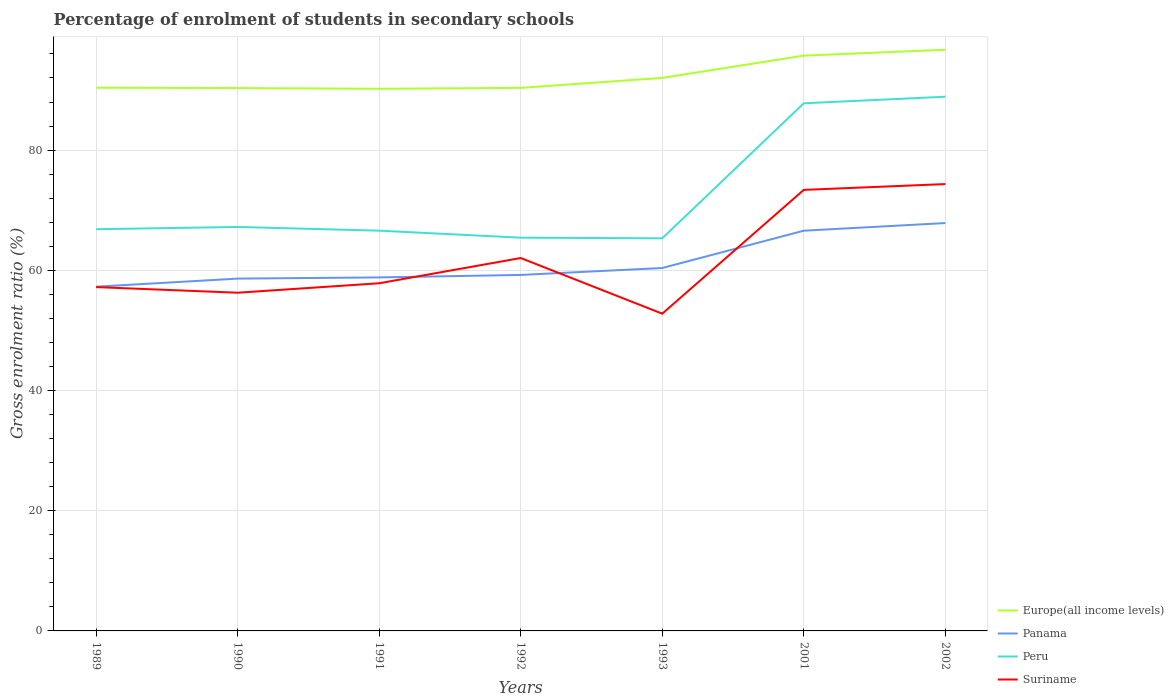How many different coloured lines are there?
Provide a short and direct response. 4. Is the number of lines equal to the number of legend labels?
Your response must be concise. Yes. Across all years, what is the maximum percentage of students enrolled in secondary schools in Europe(all income levels)?
Provide a succinct answer. 90.2. In which year was the percentage of students enrolled in secondary schools in Europe(all income levels) maximum?
Keep it short and to the point. 1991. What is the total percentage of students enrolled in secondary schools in Europe(all income levels) in the graph?
Offer a terse response. -1.66. What is the difference between the highest and the second highest percentage of students enrolled in secondary schools in Panama?
Offer a terse response. 10.59. What is the difference between the highest and the lowest percentage of students enrolled in secondary schools in Panama?
Offer a very short reply. 2. Does the graph contain grids?
Provide a short and direct response. Yes. What is the title of the graph?
Your response must be concise. Percentage of enrolment of students in secondary schools. Does "Guatemala" appear as one of the legend labels in the graph?
Make the answer very short. No. What is the Gross enrolment ratio (%) in Europe(all income levels) in 1989?
Ensure brevity in your answer.  90.38. What is the Gross enrolment ratio (%) in Panama in 1989?
Provide a succinct answer. 57.27. What is the Gross enrolment ratio (%) in Peru in 1989?
Provide a short and direct response. 66.84. What is the Gross enrolment ratio (%) of Suriname in 1989?
Keep it short and to the point. 57.21. What is the Gross enrolment ratio (%) of Europe(all income levels) in 1990?
Ensure brevity in your answer.  90.32. What is the Gross enrolment ratio (%) in Panama in 1990?
Your answer should be very brief. 58.62. What is the Gross enrolment ratio (%) of Peru in 1990?
Make the answer very short. 67.21. What is the Gross enrolment ratio (%) in Suriname in 1990?
Your answer should be compact. 56.27. What is the Gross enrolment ratio (%) in Europe(all income levels) in 1991?
Your answer should be very brief. 90.2. What is the Gross enrolment ratio (%) in Panama in 1991?
Keep it short and to the point. 58.82. What is the Gross enrolment ratio (%) in Peru in 1991?
Your answer should be compact. 66.59. What is the Gross enrolment ratio (%) in Suriname in 1991?
Your response must be concise. 57.85. What is the Gross enrolment ratio (%) of Europe(all income levels) in 1992?
Your answer should be compact. 90.36. What is the Gross enrolment ratio (%) in Panama in 1992?
Give a very brief answer. 59.23. What is the Gross enrolment ratio (%) of Peru in 1992?
Make the answer very short. 65.43. What is the Gross enrolment ratio (%) in Suriname in 1992?
Your answer should be very brief. 62.04. What is the Gross enrolment ratio (%) of Europe(all income levels) in 1993?
Ensure brevity in your answer.  92.02. What is the Gross enrolment ratio (%) in Panama in 1993?
Your answer should be very brief. 60.38. What is the Gross enrolment ratio (%) of Peru in 1993?
Provide a succinct answer. 65.32. What is the Gross enrolment ratio (%) of Suriname in 1993?
Provide a short and direct response. 52.78. What is the Gross enrolment ratio (%) in Europe(all income levels) in 2001?
Your answer should be compact. 95.72. What is the Gross enrolment ratio (%) of Panama in 2001?
Provide a short and direct response. 66.59. What is the Gross enrolment ratio (%) of Peru in 2001?
Your answer should be compact. 87.79. What is the Gross enrolment ratio (%) in Suriname in 2001?
Give a very brief answer. 73.38. What is the Gross enrolment ratio (%) in Europe(all income levels) in 2002?
Your answer should be very brief. 96.69. What is the Gross enrolment ratio (%) of Panama in 2002?
Ensure brevity in your answer.  67.86. What is the Gross enrolment ratio (%) of Peru in 2002?
Offer a very short reply. 88.88. What is the Gross enrolment ratio (%) in Suriname in 2002?
Provide a succinct answer. 74.35. Across all years, what is the maximum Gross enrolment ratio (%) of Europe(all income levels)?
Your answer should be very brief. 96.69. Across all years, what is the maximum Gross enrolment ratio (%) of Panama?
Provide a succinct answer. 67.86. Across all years, what is the maximum Gross enrolment ratio (%) of Peru?
Provide a short and direct response. 88.88. Across all years, what is the maximum Gross enrolment ratio (%) in Suriname?
Provide a succinct answer. 74.35. Across all years, what is the minimum Gross enrolment ratio (%) of Europe(all income levels)?
Offer a terse response. 90.2. Across all years, what is the minimum Gross enrolment ratio (%) of Panama?
Provide a succinct answer. 57.27. Across all years, what is the minimum Gross enrolment ratio (%) in Peru?
Give a very brief answer. 65.32. Across all years, what is the minimum Gross enrolment ratio (%) in Suriname?
Give a very brief answer. 52.78. What is the total Gross enrolment ratio (%) in Europe(all income levels) in the graph?
Offer a terse response. 645.69. What is the total Gross enrolment ratio (%) of Panama in the graph?
Make the answer very short. 428.78. What is the total Gross enrolment ratio (%) of Peru in the graph?
Keep it short and to the point. 508.06. What is the total Gross enrolment ratio (%) in Suriname in the graph?
Provide a succinct answer. 433.88. What is the difference between the Gross enrolment ratio (%) of Europe(all income levels) in 1989 and that in 1990?
Provide a short and direct response. 0.06. What is the difference between the Gross enrolment ratio (%) in Panama in 1989 and that in 1990?
Your answer should be compact. -1.34. What is the difference between the Gross enrolment ratio (%) of Peru in 1989 and that in 1990?
Offer a very short reply. -0.38. What is the difference between the Gross enrolment ratio (%) of Suriname in 1989 and that in 1990?
Your response must be concise. 0.94. What is the difference between the Gross enrolment ratio (%) of Europe(all income levels) in 1989 and that in 1991?
Provide a short and direct response. 0.18. What is the difference between the Gross enrolment ratio (%) of Panama in 1989 and that in 1991?
Offer a very short reply. -1.54. What is the difference between the Gross enrolment ratio (%) of Peru in 1989 and that in 1991?
Give a very brief answer. 0.24. What is the difference between the Gross enrolment ratio (%) of Suriname in 1989 and that in 1991?
Provide a succinct answer. -0.64. What is the difference between the Gross enrolment ratio (%) of Europe(all income levels) in 1989 and that in 1992?
Your answer should be compact. 0.03. What is the difference between the Gross enrolment ratio (%) of Panama in 1989 and that in 1992?
Offer a terse response. -1.96. What is the difference between the Gross enrolment ratio (%) in Peru in 1989 and that in 1992?
Your response must be concise. 1.41. What is the difference between the Gross enrolment ratio (%) in Suriname in 1989 and that in 1992?
Ensure brevity in your answer.  -4.84. What is the difference between the Gross enrolment ratio (%) of Europe(all income levels) in 1989 and that in 1993?
Make the answer very short. -1.63. What is the difference between the Gross enrolment ratio (%) of Panama in 1989 and that in 1993?
Make the answer very short. -3.11. What is the difference between the Gross enrolment ratio (%) in Peru in 1989 and that in 1993?
Ensure brevity in your answer.  1.51. What is the difference between the Gross enrolment ratio (%) of Suriname in 1989 and that in 1993?
Give a very brief answer. 4.42. What is the difference between the Gross enrolment ratio (%) in Europe(all income levels) in 1989 and that in 2001?
Ensure brevity in your answer.  -5.34. What is the difference between the Gross enrolment ratio (%) in Panama in 1989 and that in 2001?
Your answer should be very brief. -9.32. What is the difference between the Gross enrolment ratio (%) in Peru in 1989 and that in 2001?
Your answer should be compact. -20.95. What is the difference between the Gross enrolment ratio (%) in Suriname in 1989 and that in 2001?
Your response must be concise. -16.17. What is the difference between the Gross enrolment ratio (%) of Europe(all income levels) in 1989 and that in 2002?
Offer a very short reply. -6.31. What is the difference between the Gross enrolment ratio (%) of Panama in 1989 and that in 2002?
Your response must be concise. -10.59. What is the difference between the Gross enrolment ratio (%) in Peru in 1989 and that in 2002?
Your answer should be very brief. -22.04. What is the difference between the Gross enrolment ratio (%) of Suriname in 1989 and that in 2002?
Your response must be concise. -17.14. What is the difference between the Gross enrolment ratio (%) of Europe(all income levels) in 1990 and that in 1991?
Offer a terse response. 0.12. What is the difference between the Gross enrolment ratio (%) of Panama in 1990 and that in 1991?
Provide a short and direct response. -0.2. What is the difference between the Gross enrolment ratio (%) in Peru in 1990 and that in 1991?
Your answer should be very brief. 0.62. What is the difference between the Gross enrolment ratio (%) of Suriname in 1990 and that in 1991?
Your answer should be very brief. -1.57. What is the difference between the Gross enrolment ratio (%) in Europe(all income levels) in 1990 and that in 1992?
Provide a succinct answer. -0.04. What is the difference between the Gross enrolment ratio (%) in Panama in 1990 and that in 1992?
Your response must be concise. -0.61. What is the difference between the Gross enrolment ratio (%) of Peru in 1990 and that in 1992?
Ensure brevity in your answer.  1.79. What is the difference between the Gross enrolment ratio (%) of Suriname in 1990 and that in 1992?
Provide a short and direct response. -5.77. What is the difference between the Gross enrolment ratio (%) of Europe(all income levels) in 1990 and that in 1993?
Offer a very short reply. -1.69. What is the difference between the Gross enrolment ratio (%) in Panama in 1990 and that in 1993?
Provide a short and direct response. -1.76. What is the difference between the Gross enrolment ratio (%) in Peru in 1990 and that in 1993?
Ensure brevity in your answer.  1.89. What is the difference between the Gross enrolment ratio (%) of Suriname in 1990 and that in 1993?
Provide a succinct answer. 3.49. What is the difference between the Gross enrolment ratio (%) in Europe(all income levels) in 1990 and that in 2001?
Make the answer very short. -5.4. What is the difference between the Gross enrolment ratio (%) in Panama in 1990 and that in 2001?
Provide a succinct answer. -7.97. What is the difference between the Gross enrolment ratio (%) in Peru in 1990 and that in 2001?
Give a very brief answer. -20.57. What is the difference between the Gross enrolment ratio (%) of Suriname in 1990 and that in 2001?
Your answer should be very brief. -17.11. What is the difference between the Gross enrolment ratio (%) of Europe(all income levels) in 1990 and that in 2002?
Ensure brevity in your answer.  -6.37. What is the difference between the Gross enrolment ratio (%) in Panama in 1990 and that in 2002?
Offer a very short reply. -9.24. What is the difference between the Gross enrolment ratio (%) of Peru in 1990 and that in 2002?
Your response must be concise. -21.67. What is the difference between the Gross enrolment ratio (%) in Suriname in 1990 and that in 2002?
Offer a very short reply. -18.07. What is the difference between the Gross enrolment ratio (%) in Europe(all income levels) in 1991 and that in 1992?
Your answer should be compact. -0.16. What is the difference between the Gross enrolment ratio (%) of Panama in 1991 and that in 1992?
Provide a short and direct response. -0.41. What is the difference between the Gross enrolment ratio (%) of Peru in 1991 and that in 1992?
Make the answer very short. 1.17. What is the difference between the Gross enrolment ratio (%) in Suriname in 1991 and that in 1992?
Provide a succinct answer. -4.2. What is the difference between the Gross enrolment ratio (%) in Europe(all income levels) in 1991 and that in 1993?
Provide a short and direct response. -1.81. What is the difference between the Gross enrolment ratio (%) in Panama in 1991 and that in 1993?
Ensure brevity in your answer.  -1.56. What is the difference between the Gross enrolment ratio (%) in Peru in 1991 and that in 1993?
Your answer should be compact. 1.27. What is the difference between the Gross enrolment ratio (%) of Suriname in 1991 and that in 1993?
Offer a very short reply. 5.06. What is the difference between the Gross enrolment ratio (%) of Europe(all income levels) in 1991 and that in 2001?
Provide a short and direct response. -5.52. What is the difference between the Gross enrolment ratio (%) in Panama in 1991 and that in 2001?
Offer a terse response. -7.77. What is the difference between the Gross enrolment ratio (%) in Peru in 1991 and that in 2001?
Ensure brevity in your answer.  -21.19. What is the difference between the Gross enrolment ratio (%) in Suriname in 1991 and that in 2001?
Offer a very short reply. -15.54. What is the difference between the Gross enrolment ratio (%) in Europe(all income levels) in 1991 and that in 2002?
Give a very brief answer. -6.49. What is the difference between the Gross enrolment ratio (%) of Panama in 1991 and that in 2002?
Ensure brevity in your answer.  -9.04. What is the difference between the Gross enrolment ratio (%) of Peru in 1991 and that in 2002?
Provide a short and direct response. -22.28. What is the difference between the Gross enrolment ratio (%) of Suriname in 1991 and that in 2002?
Keep it short and to the point. -16.5. What is the difference between the Gross enrolment ratio (%) of Europe(all income levels) in 1992 and that in 1993?
Provide a succinct answer. -1.66. What is the difference between the Gross enrolment ratio (%) of Panama in 1992 and that in 1993?
Your answer should be very brief. -1.15. What is the difference between the Gross enrolment ratio (%) in Peru in 1992 and that in 1993?
Give a very brief answer. 0.1. What is the difference between the Gross enrolment ratio (%) in Suriname in 1992 and that in 1993?
Offer a very short reply. 9.26. What is the difference between the Gross enrolment ratio (%) of Europe(all income levels) in 1992 and that in 2001?
Your answer should be compact. -5.36. What is the difference between the Gross enrolment ratio (%) of Panama in 1992 and that in 2001?
Provide a short and direct response. -7.36. What is the difference between the Gross enrolment ratio (%) in Peru in 1992 and that in 2001?
Keep it short and to the point. -22.36. What is the difference between the Gross enrolment ratio (%) in Suriname in 1992 and that in 2001?
Your answer should be very brief. -11.34. What is the difference between the Gross enrolment ratio (%) in Europe(all income levels) in 1992 and that in 2002?
Ensure brevity in your answer.  -6.34. What is the difference between the Gross enrolment ratio (%) in Panama in 1992 and that in 2002?
Your answer should be very brief. -8.63. What is the difference between the Gross enrolment ratio (%) in Peru in 1992 and that in 2002?
Offer a terse response. -23.45. What is the difference between the Gross enrolment ratio (%) in Suriname in 1992 and that in 2002?
Ensure brevity in your answer.  -12.3. What is the difference between the Gross enrolment ratio (%) of Europe(all income levels) in 1993 and that in 2001?
Your answer should be very brief. -3.71. What is the difference between the Gross enrolment ratio (%) of Panama in 1993 and that in 2001?
Provide a short and direct response. -6.21. What is the difference between the Gross enrolment ratio (%) in Peru in 1993 and that in 2001?
Offer a terse response. -22.46. What is the difference between the Gross enrolment ratio (%) in Suriname in 1993 and that in 2001?
Keep it short and to the point. -20.6. What is the difference between the Gross enrolment ratio (%) in Europe(all income levels) in 1993 and that in 2002?
Offer a very short reply. -4.68. What is the difference between the Gross enrolment ratio (%) in Panama in 1993 and that in 2002?
Ensure brevity in your answer.  -7.48. What is the difference between the Gross enrolment ratio (%) of Peru in 1993 and that in 2002?
Provide a succinct answer. -23.56. What is the difference between the Gross enrolment ratio (%) of Suriname in 1993 and that in 2002?
Offer a terse response. -21.56. What is the difference between the Gross enrolment ratio (%) in Europe(all income levels) in 2001 and that in 2002?
Ensure brevity in your answer.  -0.97. What is the difference between the Gross enrolment ratio (%) in Panama in 2001 and that in 2002?
Offer a very short reply. -1.27. What is the difference between the Gross enrolment ratio (%) in Peru in 2001 and that in 2002?
Your answer should be compact. -1.09. What is the difference between the Gross enrolment ratio (%) in Suriname in 2001 and that in 2002?
Provide a short and direct response. -0.96. What is the difference between the Gross enrolment ratio (%) in Europe(all income levels) in 1989 and the Gross enrolment ratio (%) in Panama in 1990?
Make the answer very short. 31.76. What is the difference between the Gross enrolment ratio (%) in Europe(all income levels) in 1989 and the Gross enrolment ratio (%) in Peru in 1990?
Your response must be concise. 23.17. What is the difference between the Gross enrolment ratio (%) in Europe(all income levels) in 1989 and the Gross enrolment ratio (%) in Suriname in 1990?
Make the answer very short. 34.11. What is the difference between the Gross enrolment ratio (%) in Panama in 1989 and the Gross enrolment ratio (%) in Peru in 1990?
Your answer should be very brief. -9.94. What is the difference between the Gross enrolment ratio (%) of Peru in 1989 and the Gross enrolment ratio (%) of Suriname in 1990?
Give a very brief answer. 10.56. What is the difference between the Gross enrolment ratio (%) in Europe(all income levels) in 1989 and the Gross enrolment ratio (%) in Panama in 1991?
Give a very brief answer. 31.56. What is the difference between the Gross enrolment ratio (%) in Europe(all income levels) in 1989 and the Gross enrolment ratio (%) in Peru in 1991?
Give a very brief answer. 23.79. What is the difference between the Gross enrolment ratio (%) in Europe(all income levels) in 1989 and the Gross enrolment ratio (%) in Suriname in 1991?
Keep it short and to the point. 32.54. What is the difference between the Gross enrolment ratio (%) in Panama in 1989 and the Gross enrolment ratio (%) in Peru in 1991?
Provide a short and direct response. -9.32. What is the difference between the Gross enrolment ratio (%) of Panama in 1989 and the Gross enrolment ratio (%) of Suriname in 1991?
Offer a terse response. -0.57. What is the difference between the Gross enrolment ratio (%) of Peru in 1989 and the Gross enrolment ratio (%) of Suriname in 1991?
Ensure brevity in your answer.  8.99. What is the difference between the Gross enrolment ratio (%) in Europe(all income levels) in 1989 and the Gross enrolment ratio (%) in Panama in 1992?
Give a very brief answer. 31.15. What is the difference between the Gross enrolment ratio (%) in Europe(all income levels) in 1989 and the Gross enrolment ratio (%) in Peru in 1992?
Provide a short and direct response. 24.96. What is the difference between the Gross enrolment ratio (%) of Europe(all income levels) in 1989 and the Gross enrolment ratio (%) of Suriname in 1992?
Your answer should be compact. 28.34. What is the difference between the Gross enrolment ratio (%) of Panama in 1989 and the Gross enrolment ratio (%) of Peru in 1992?
Your answer should be very brief. -8.15. What is the difference between the Gross enrolment ratio (%) of Panama in 1989 and the Gross enrolment ratio (%) of Suriname in 1992?
Offer a very short reply. -4.77. What is the difference between the Gross enrolment ratio (%) of Peru in 1989 and the Gross enrolment ratio (%) of Suriname in 1992?
Make the answer very short. 4.79. What is the difference between the Gross enrolment ratio (%) in Europe(all income levels) in 1989 and the Gross enrolment ratio (%) in Panama in 1993?
Keep it short and to the point. 30. What is the difference between the Gross enrolment ratio (%) of Europe(all income levels) in 1989 and the Gross enrolment ratio (%) of Peru in 1993?
Offer a very short reply. 25.06. What is the difference between the Gross enrolment ratio (%) of Europe(all income levels) in 1989 and the Gross enrolment ratio (%) of Suriname in 1993?
Offer a very short reply. 37.6. What is the difference between the Gross enrolment ratio (%) in Panama in 1989 and the Gross enrolment ratio (%) in Peru in 1993?
Your answer should be compact. -8.05. What is the difference between the Gross enrolment ratio (%) of Panama in 1989 and the Gross enrolment ratio (%) of Suriname in 1993?
Keep it short and to the point. 4.49. What is the difference between the Gross enrolment ratio (%) in Peru in 1989 and the Gross enrolment ratio (%) in Suriname in 1993?
Your response must be concise. 14.05. What is the difference between the Gross enrolment ratio (%) of Europe(all income levels) in 1989 and the Gross enrolment ratio (%) of Panama in 2001?
Offer a terse response. 23.79. What is the difference between the Gross enrolment ratio (%) in Europe(all income levels) in 1989 and the Gross enrolment ratio (%) in Peru in 2001?
Your answer should be compact. 2.6. What is the difference between the Gross enrolment ratio (%) in Europe(all income levels) in 1989 and the Gross enrolment ratio (%) in Suriname in 2001?
Keep it short and to the point. 17. What is the difference between the Gross enrolment ratio (%) in Panama in 1989 and the Gross enrolment ratio (%) in Peru in 2001?
Make the answer very short. -30.51. What is the difference between the Gross enrolment ratio (%) of Panama in 1989 and the Gross enrolment ratio (%) of Suriname in 2001?
Offer a terse response. -16.11. What is the difference between the Gross enrolment ratio (%) in Peru in 1989 and the Gross enrolment ratio (%) in Suriname in 2001?
Your answer should be very brief. -6.55. What is the difference between the Gross enrolment ratio (%) of Europe(all income levels) in 1989 and the Gross enrolment ratio (%) of Panama in 2002?
Offer a terse response. 22.52. What is the difference between the Gross enrolment ratio (%) in Europe(all income levels) in 1989 and the Gross enrolment ratio (%) in Peru in 2002?
Your answer should be very brief. 1.5. What is the difference between the Gross enrolment ratio (%) of Europe(all income levels) in 1989 and the Gross enrolment ratio (%) of Suriname in 2002?
Give a very brief answer. 16.04. What is the difference between the Gross enrolment ratio (%) in Panama in 1989 and the Gross enrolment ratio (%) in Peru in 2002?
Offer a terse response. -31.6. What is the difference between the Gross enrolment ratio (%) in Panama in 1989 and the Gross enrolment ratio (%) in Suriname in 2002?
Your answer should be very brief. -17.07. What is the difference between the Gross enrolment ratio (%) of Peru in 1989 and the Gross enrolment ratio (%) of Suriname in 2002?
Offer a terse response. -7.51. What is the difference between the Gross enrolment ratio (%) in Europe(all income levels) in 1990 and the Gross enrolment ratio (%) in Panama in 1991?
Offer a very short reply. 31.5. What is the difference between the Gross enrolment ratio (%) in Europe(all income levels) in 1990 and the Gross enrolment ratio (%) in Peru in 1991?
Your answer should be compact. 23.73. What is the difference between the Gross enrolment ratio (%) of Europe(all income levels) in 1990 and the Gross enrolment ratio (%) of Suriname in 1991?
Make the answer very short. 32.48. What is the difference between the Gross enrolment ratio (%) of Panama in 1990 and the Gross enrolment ratio (%) of Peru in 1991?
Offer a terse response. -7.98. What is the difference between the Gross enrolment ratio (%) of Panama in 1990 and the Gross enrolment ratio (%) of Suriname in 1991?
Your answer should be very brief. 0.77. What is the difference between the Gross enrolment ratio (%) of Peru in 1990 and the Gross enrolment ratio (%) of Suriname in 1991?
Your response must be concise. 9.37. What is the difference between the Gross enrolment ratio (%) of Europe(all income levels) in 1990 and the Gross enrolment ratio (%) of Panama in 1992?
Offer a very short reply. 31.09. What is the difference between the Gross enrolment ratio (%) in Europe(all income levels) in 1990 and the Gross enrolment ratio (%) in Peru in 1992?
Offer a very short reply. 24.9. What is the difference between the Gross enrolment ratio (%) of Europe(all income levels) in 1990 and the Gross enrolment ratio (%) of Suriname in 1992?
Ensure brevity in your answer.  28.28. What is the difference between the Gross enrolment ratio (%) of Panama in 1990 and the Gross enrolment ratio (%) of Peru in 1992?
Ensure brevity in your answer.  -6.81. What is the difference between the Gross enrolment ratio (%) of Panama in 1990 and the Gross enrolment ratio (%) of Suriname in 1992?
Provide a short and direct response. -3.42. What is the difference between the Gross enrolment ratio (%) of Peru in 1990 and the Gross enrolment ratio (%) of Suriname in 1992?
Your answer should be compact. 5.17. What is the difference between the Gross enrolment ratio (%) of Europe(all income levels) in 1990 and the Gross enrolment ratio (%) of Panama in 1993?
Offer a terse response. 29.94. What is the difference between the Gross enrolment ratio (%) in Europe(all income levels) in 1990 and the Gross enrolment ratio (%) in Peru in 1993?
Keep it short and to the point. 25. What is the difference between the Gross enrolment ratio (%) of Europe(all income levels) in 1990 and the Gross enrolment ratio (%) of Suriname in 1993?
Offer a terse response. 37.54. What is the difference between the Gross enrolment ratio (%) of Panama in 1990 and the Gross enrolment ratio (%) of Peru in 1993?
Offer a terse response. -6.7. What is the difference between the Gross enrolment ratio (%) of Panama in 1990 and the Gross enrolment ratio (%) of Suriname in 1993?
Offer a very short reply. 5.84. What is the difference between the Gross enrolment ratio (%) in Peru in 1990 and the Gross enrolment ratio (%) in Suriname in 1993?
Your answer should be compact. 14.43. What is the difference between the Gross enrolment ratio (%) in Europe(all income levels) in 1990 and the Gross enrolment ratio (%) in Panama in 2001?
Provide a short and direct response. 23.73. What is the difference between the Gross enrolment ratio (%) in Europe(all income levels) in 1990 and the Gross enrolment ratio (%) in Peru in 2001?
Provide a succinct answer. 2.53. What is the difference between the Gross enrolment ratio (%) in Europe(all income levels) in 1990 and the Gross enrolment ratio (%) in Suriname in 2001?
Keep it short and to the point. 16.94. What is the difference between the Gross enrolment ratio (%) of Panama in 1990 and the Gross enrolment ratio (%) of Peru in 2001?
Your response must be concise. -29.17. What is the difference between the Gross enrolment ratio (%) of Panama in 1990 and the Gross enrolment ratio (%) of Suriname in 2001?
Your answer should be compact. -14.76. What is the difference between the Gross enrolment ratio (%) of Peru in 1990 and the Gross enrolment ratio (%) of Suriname in 2001?
Your answer should be compact. -6.17. What is the difference between the Gross enrolment ratio (%) of Europe(all income levels) in 1990 and the Gross enrolment ratio (%) of Panama in 2002?
Provide a short and direct response. 22.46. What is the difference between the Gross enrolment ratio (%) of Europe(all income levels) in 1990 and the Gross enrolment ratio (%) of Peru in 2002?
Provide a short and direct response. 1.44. What is the difference between the Gross enrolment ratio (%) of Europe(all income levels) in 1990 and the Gross enrolment ratio (%) of Suriname in 2002?
Your response must be concise. 15.98. What is the difference between the Gross enrolment ratio (%) in Panama in 1990 and the Gross enrolment ratio (%) in Peru in 2002?
Provide a succinct answer. -30.26. What is the difference between the Gross enrolment ratio (%) in Panama in 1990 and the Gross enrolment ratio (%) in Suriname in 2002?
Your answer should be compact. -15.73. What is the difference between the Gross enrolment ratio (%) of Peru in 1990 and the Gross enrolment ratio (%) of Suriname in 2002?
Provide a succinct answer. -7.13. What is the difference between the Gross enrolment ratio (%) in Europe(all income levels) in 1991 and the Gross enrolment ratio (%) in Panama in 1992?
Your answer should be very brief. 30.97. What is the difference between the Gross enrolment ratio (%) in Europe(all income levels) in 1991 and the Gross enrolment ratio (%) in Peru in 1992?
Ensure brevity in your answer.  24.78. What is the difference between the Gross enrolment ratio (%) of Europe(all income levels) in 1991 and the Gross enrolment ratio (%) of Suriname in 1992?
Keep it short and to the point. 28.16. What is the difference between the Gross enrolment ratio (%) in Panama in 1991 and the Gross enrolment ratio (%) in Peru in 1992?
Ensure brevity in your answer.  -6.61. What is the difference between the Gross enrolment ratio (%) of Panama in 1991 and the Gross enrolment ratio (%) of Suriname in 1992?
Give a very brief answer. -3.22. What is the difference between the Gross enrolment ratio (%) in Peru in 1991 and the Gross enrolment ratio (%) in Suriname in 1992?
Your response must be concise. 4.55. What is the difference between the Gross enrolment ratio (%) in Europe(all income levels) in 1991 and the Gross enrolment ratio (%) in Panama in 1993?
Your response must be concise. 29.82. What is the difference between the Gross enrolment ratio (%) of Europe(all income levels) in 1991 and the Gross enrolment ratio (%) of Peru in 1993?
Ensure brevity in your answer.  24.88. What is the difference between the Gross enrolment ratio (%) in Europe(all income levels) in 1991 and the Gross enrolment ratio (%) in Suriname in 1993?
Give a very brief answer. 37.42. What is the difference between the Gross enrolment ratio (%) of Panama in 1991 and the Gross enrolment ratio (%) of Peru in 1993?
Ensure brevity in your answer.  -6.5. What is the difference between the Gross enrolment ratio (%) in Panama in 1991 and the Gross enrolment ratio (%) in Suriname in 1993?
Make the answer very short. 6.04. What is the difference between the Gross enrolment ratio (%) of Peru in 1991 and the Gross enrolment ratio (%) of Suriname in 1993?
Make the answer very short. 13.81. What is the difference between the Gross enrolment ratio (%) of Europe(all income levels) in 1991 and the Gross enrolment ratio (%) of Panama in 2001?
Offer a terse response. 23.61. What is the difference between the Gross enrolment ratio (%) in Europe(all income levels) in 1991 and the Gross enrolment ratio (%) in Peru in 2001?
Your answer should be very brief. 2.41. What is the difference between the Gross enrolment ratio (%) of Europe(all income levels) in 1991 and the Gross enrolment ratio (%) of Suriname in 2001?
Make the answer very short. 16.82. What is the difference between the Gross enrolment ratio (%) in Panama in 1991 and the Gross enrolment ratio (%) in Peru in 2001?
Provide a short and direct response. -28.97. What is the difference between the Gross enrolment ratio (%) of Panama in 1991 and the Gross enrolment ratio (%) of Suriname in 2001?
Make the answer very short. -14.56. What is the difference between the Gross enrolment ratio (%) in Peru in 1991 and the Gross enrolment ratio (%) in Suriname in 2001?
Provide a short and direct response. -6.79. What is the difference between the Gross enrolment ratio (%) of Europe(all income levels) in 1991 and the Gross enrolment ratio (%) of Panama in 2002?
Offer a terse response. 22.34. What is the difference between the Gross enrolment ratio (%) of Europe(all income levels) in 1991 and the Gross enrolment ratio (%) of Peru in 2002?
Give a very brief answer. 1.32. What is the difference between the Gross enrolment ratio (%) of Europe(all income levels) in 1991 and the Gross enrolment ratio (%) of Suriname in 2002?
Provide a short and direct response. 15.86. What is the difference between the Gross enrolment ratio (%) of Panama in 1991 and the Gross enrolment ratio (%) of Peru in 2002?
Your answer should be compact. -30.06. What is the difference between the Gross enrolment ratio (%) of Panama in 1991 and the Gross enrolment ratio (%) of Suriname in 2002?
Make the answer very short. -15.53. What is the difference between the Gross enrolment ratio (%) in Peru in 1991 and the Gross enrolment ratio (%) in Suriname in 2002?
Offer a very short reply. -7.75. What is the difference between the Gross enrolment ratio (%) in Europe(all income levels) in 1992 and the Gross enrolment ratio (%) in Panama in 1993?
Keep it short and to the point. 29.98. What is the difference between the Gross enrolment ratio (%) in Europe(all income levels) in 1992 and the Gross enrolment ratio (%) in Peru in 1993?
Offer a terse response. 25.03. What is the difference between the Gross enrolment ratio (%) in Europe(all income levels) in 1992 and the Gross enrolment ratio (%) in Suriname in 1993?
Provide a short and direct response. 37.57. What is the difference between the Gross enrolment ratio (%) in Panama in 1992 and the Gross enrolment ratio (%) in Peru in 1993?
Provide a succinct answer. -6.09. What is the difference between the Gross enrolment ratio (%) in Panama in 1992 and the Gross enrolment ratio (%) in Suriname in 1993?
Provide a short and direct response. 6.45. What is the difference between the Gross enrolment ratio (%) of Peru in 1992 and the Gross enrolment ratio (%) of Suriname in 1993?
Ensure brevity in your answer.  12.64. What is the difference between the Gross enrolment ratio (%) in Europe(all income levels) in 1992 and the Gross enrolment ratio (%) in Panama in 2001?
Give a very brief answer. 23.77. What is the difference between the Gross enrolment ratio (%) of Europe(all income levels) in 1992 and the Gross enrolment ratio (%) of Peru in 2001?
Make the answer very short. 2.57. What is the difference between the Gross enrolment ratio (%) in Europe(all income levels) in 1992 and the Gross enrolment ratio (%) in Suriname in 2001?
Your answer should be compact. 16.98. What is the difference between the Gross enrolment ratio (%) in Panama in 1992 and the Gross enrolment ratio (%) in Peru in 2001?
Offer a terse response. -28.56. What is the difference between the Gross enrolment ratio (%) in Panama in 1992 and the Gross enrolment ratio (%) in Suriname in 2001?
Keep it short and to the point. -14.15. What is the difference between the Gross enrolment ratio (%) of Peru in 1992 and the Gross enrolment ratio (%) of Suriname in 2001?
Offer a terse response. -7.96. What is the difference between the Gross enrolment ratio (%) in Europe(all income levels) in 1992 and the Gross enrolment ratio (%) in Panama in 2002?
Keep it short and to the point. 22.5. What is the difference between the Gross enrolment ratio (%) in Europe(all income levels) in 1992 and the Gross enrolment ratio (%) in Peru in 2002?
Keep it short and to the point. 1.48. What is the difference between the Gross enrolment ratio (%) of Europe(all income levels) in 1992 and the Gross enrolment ratio (%) of Suriname in 2002?
Your answer should be very brief. 16.01. What is the difference between the Gross enrolment ratio (%) in Panama in 1992 and the Gross enrolment ratio (%) in Peru in 2002?
Give a very brief answer. -29.65. What is the difference between the Gross enrolment ratio (%) of Panama in 1992 and the Gross enrolment ratio (%) of Suriname in 2002?
Keep it short and to the point. -15.12. What is the difference between the Gross enrolment ratio (%) in Peru in 1992 and the Gross enrolment ratio (%) in Suriname in 2002?
Offer a very short reply. -8.92. What is the difference between the Gross enrolment ratio (%) of Europe(all income levels) in 1993 and the Gross enrolment ratio (%) of Panama in 2001?
Make the answer very short. 25.43. What is the difference between the Gross enrolment ratio (%) of Europe(all income levels) in 1993 and the Gross enrolment ratio (%) of Peru in 2001?
Your answer should be very brief. 4.23. What is the difference between the Gross enrolment ratio (%) of Europe(all income levels) in 1993 and the Gross enrolment ratio (%) of Suriname in 2001?
Give a very brief answer. 18.63. What is the difference between the Gross enrolment ratio (%) in Panama in 1993 and the Gross enrolment ratio (%) in Peru in 2001?
Provide a short and direct response. -27.41. What is the difference between the Gross enrolment ratio (%) of Panama in 1993 and the Gross enrolment ratio (%) of Suriname in 2001?
Make the answer very short. -13. What is the difference between the Gross enrolment ratio (%) in Peru in 1993 and the Gross enrolment ratio (%) in Suriname in 2001?
Your answer should be very brief. -8.06. What is the difference between the Gross enrolment ratio (%) in Europe(all income levels) in 1993 and the Gross enrolment ratio (%) in Panama in 2002?
Give a very brief answer. 24.16. What is the difference between the Gross enrolment ratio (%) of Europe(all income levels) in 1993 and the Gross enrolment ratio (%) of Peru in 2002?
Offer a terse response. 3.14. What is the difference between the Gross enrolment ratio (%) of Europe(all income levels) in 1993 and the Gross enrolment ratio (%) of Suriname in 2002?
Your answer should be very brief. 17.67. What is the difference between the Gross enrolment ratio (%) of Panama in 1993 and the Gross enrolment ratio (%) of Peru in 2002?
Provide a succinct answer. -28.5. What is the difference between the Gross enrolment ratio (%) in Panama in 1993 and the Gross enrolment ratio (%) in Suriname in 2002?
Your response must be concise. -13.97. What is the difference between the Gross enrolment ratio (%) of Peru in 1993 and the Gross enrolment ratio (%) of Suriname in 2002?
Make the answer very short. -9.02. What is the difference between the Gross enrolment ratio (%) of Europe(all income levels) in 2001 and the Gross enrolment ratio (%) of Panama in 2002?
Make the answer very short. 27.86. What is the difference between the Gross enrolment ratio (%) of Europe(all income levels) in 2001 and the Gross enrolment ratio (%) of Peru in 2002?
Offer a very short reply. 6.84. What is the difference between the Gross enrolment ratio (%) of Europe(all income levels) in 2001 and the Gross enrolment ratio (%) of Suriname in 2002?
Your answer should be very brief. 21.38. What is the difference between the Gross enrolment ratio (%) of Panama in 2001 and the Gross enrolment ratio (%) of Peru in 2002?
Your answer should be compact. -22.29. What is the difference between the Gross enrolment ratio (%) in Panama in 2001 and the Gross enrolment ratio (%) in Suriname in 2002?
Ensure brevity in your answer.  -7.75. What is the difference between the Gross enrolment ratio (%) of Peru in 2001 and the Gross enrolment ratio (%) of Suriname in 2002?
Keep it short and to the point. 13.44. What is the average Gross enrolment ratio (%) in Europe(all income levels) per year?
Give a very brief answer. 92.24. What is the average Gross enrolment ratio (%) in Panama per year?
Offer a terse response. 61.25. What is the average Gross enrolment ratio (%) of Peru per year?
Your answer should be very brief. 72.58. What is the average Gross enrolment ratio (%) in Suriname per year?
Offer a terse response. 61.98. In the year 1989, what is the difference between the Gross enrolment ratio (%) in Europe(all income levels) and Gross enrolment ratio (%) in Panama?
Your answer should be very brief. 33.11. In the year 1989, what is the difference between the Gross enrolment ratio (%) of Europe(all income levels) and Gross enrolment ratio (%) of Peru?
Offer a terse response. 23.55. In the year 1989, what is the difference between the Gross enrolment ratio (%) of Europe(all income levels) and Gross enrolment ratio (%) of Suriname?
Keep it short and to the point. 33.17. In the year 1989, what is the difference between the Gross enrolment ratio (%) in Panama and Gross enrolment ratio (%) in Peru?
Ensure brevity in your answer.  -9.56. In the year 1989, what is the difference between the Gross enrolment ratio (%) of Panama and Gross enrolment ratio (%) of Suriname?
Ensure brevity in your answer.  0.07. In the year 1989, what is the difference between the Gross enrolment ratio (%) in Peru and Gross enrolment ratio (%) in Suriname?
Your answer should be compact. 9.63. In the year 1990, what is the difference between the Gross enrolment ratio (%) in Europe(all income levels) and Gross enrolment ratio (%) in Panama?
Keep it short and to the point. 31.7. In the year 1990, what is the difference between the Gross enrolment ratio (%) of Europe(all income levels) and Gross enrolment ratio (%) of Peru?
Offer a very short reply. 23.11. In the year 1990, what is the difference between the Gross enrolment ratio (%) of Europe(all income levels) and Gross enrolment ratio (%) of Suriname?
Your answer should be compact. 34.05. In the year 1990, what is the difference between the Gross enrolment ratio (%) in Panama and Gross enrolment ratio (%) in Peru?
Your answer should be compact. -8.59. In the year 1990, what is the difference between the Gross enrolment ratio (%) in Panama and Gross enrolment ratio (%) in Suriname?
Make the answer very short. 2.35. In the year 1990, what is the difference between the Gross enrolment ratio (%) in Peru and Gross enrolment ratio (%) in Suriname?
Provide a succinct answer. 10.94. In the year 1991, what is the difference between the Gross enrolment ratio (%) in Europe(all income levels) and Gross enrolment ratio (%) in Panama?
Offer a terse response. 31.38. In the year 1991, what is the difference between the Gross enrolment ratio (%) of Europe(all income levels) and Gross enrolment ratio (%) of Peru?
Provide a succinct answer. 23.61. In the year 1991, what is the difference between the Gross enrolment ratio (%) of Europe(all income levels) and Gross enrolment ratio (%) of Suriname?
Provide a short and direct response. 32.36. In the year 1991, what is the difference between the Gross enrolment ratio (%) in Panama and Gross enrolment ratio (%) in Peru?
Ensure brevity in your answer.  -7.78. In the year 1991, what is the difference between the Gross enrolment ratio (%) of Panama and Gross enrolment ratio (%) of Suriname?
Make the answer very short. 0.97. In the year 1991, what is the difference between the Gross enrolment ratio (%) in Peru and Gross enrolment ratio (%) in Suriname?
Your answer should be compact. 8.75. In the year 1992, what is the difference between the Gross enrolment ratio (%) in Europe(all income levels) and Gross enrolment ratio (%) in Panama?
Offer a very short reply. 31.13. In the year 1992, what is the difference between the Gross enrolment ratio (%) of Europe(all income levels) and Gross enrolment ratio (%) of Peru?
Your answer should be compact. 24.93. In the year 1992, what is the difference between the Gross enrolment ratio (%) of Europe(all income levels) and Gross enrolment ratio (%) of Suriname?
Your response must be concise. 28.31. In the year 1992, what is the difference between the Gross enrolment ratio (%) in Panama and Gross enrolment ratio (%) in Peru?
Your response must be concise. -6.2. In the year 1992, what is the difference between the Gross enrolment ratio (%) in Panama and Gross enrolment ratio (%) in Suriname?
Offer a very short reply. -2.81. In the year 1992, what is the difference between the Gross enrolment ratio (%) in Peru and Gross enrolment ratio (%) in Suriname?
Your answer should be compact. 3.38. In the year 1993, what is the difference between the Gross enrolment ratio (%) of Europe(all income levels) and Gross enrolment ratio (%) of Panama?
Provide a short and direct response. 31.64. In the year 1993, what is the difference between the Gross enrolment ratio (%) in Europe(all income levels) and Gross enrolment ratio (%) in Peru?
Make the answer very short. 26.69. In the year 1993, what is the difference between the Gross enrolment ratio (%) in Europe(all income levels) and Gross enrolment ratio (%) in Suriname?
Provide a short and direct response. 39.23. In the year 1993, what is the difference between the Gross enrolment ratio (%) of Panama and Gross enrolment ratio (%) of Peru?
Your response must be concise. -4.94. In the year 1993, what is the difference between the Gross enrolment ratio (%) of Panama and Gross enrolment ratio (%) of Suriname?
Provide a succinct answer. 7.6. In the year 1993, what is the difference between the Gross enrolment ratio (%) of Peru and Gross enrolment ratio (%) of Suriname?
Your answer should be very brief. 12.54. In the year 2001, what is the difference between the Gross enrolment ratio (%) of Europe(all income levels) and Gross enrolment ratio (%) of Panama?
Ensure brevity in your answer.  29.13. In the year 2001, what is the difference between the Gross enrolment ratio (%) of Europe(all income levels) and Gross enrolment ratio (%) of Peru?
Offer a very short reply. 7.93. In the year 2001, what is the difference between the Gross enrolment ratio (%) of Europe(all income levels) and Gross enrolment ratio (%) of Suriname?
Offer a terse response. 22.34. In the year 2001, what is the difference between the Gross enrolment ratio (%) of Panama and Gross enrolment ratio (%) of Peru?
Your response must be concise. -21.2. In the year 2001, what is the difference between the Gross enrolment ratio (%) of Panama and Gross enrolment ratio (%) of Suriname?
Ensure brevity in your answer.  -6.79. In the year 2001, what is the difference between the Gross enrolment ratio (%) in Peru and Gross enrolment ratio (%) in Suriname?
Give a very brief answer. 14.41. In the year 2002, what is the difference between the Gross enrolment ratio (%) of Europe(all income levels) and Gross enrolment ratio (%) of Panama?
Offer a very short reply. 28.83. In the year 2002, what is the difference between the Gross enrolment ratio (%) of Europe(all income levels) and Gross enrolment ratio (%) of Peru?
Your answer should be compact. 7.81. In the year 2002, what is the difference between the Gross enrolment ratio (%) in Europe(all income levels) and Gross enrolment ratio (%) in Suriname?
Provide a succinct answer. 22.35. In the year 2002, what is the difference between the Gross enrolment ratio (%) of Panama and Gross enrolment ratio (%) of Peru?
Provide a short and direct response. -21.02. In the year 2002, what is the difference between the Gross enrolment ratio (%) in Panama and Gross enrolment ratio (%) in Suriname?
Give a very brief answer. -6.49. In the year 2002, what is the difference between the Gross enrolment ratio (%) of Peru and Gross enrolment ratio (%) of Suriname?
Your response must be concise. 14.53. What is the ratio of the Gross enrolment ratio (%) of Europe(all income levels) in 1989 to that in 1990?
Keep it short and to the point. 1. What is the ratio of the Gross enrolment ratio (%) in Panama in 1989 to that in 1990?
Give a very brief answer. 0.98. What is the ratio of the Gross enrolment ratio (%) in Suriname in 1989 to that in 1990?
Make the answer very short. 1.02. What is the ratio of the Gross enrolment ratio (%) in Panama in 1989 to that in 1991?
Ensure brevity in your answer.  0.97. What is the ratio of the Gross enrolment ratio (%) of Peru in 1989 to that in 1991?
Offer a very short reply. 1. What is the ratio of the Gross enrolment ratio (%) in Suriname in 1989 to that in 1991?
Give a very brief answer. 0.99. What is the ratio of the Gross enrolment ratio (%) in Europe(all income levels) in 1989 to that in 1992?
Offer a terse response. 1. What is the ratio of the Gross enrolment ratio (%) of Panama in 1989 to that in 1992?
Ensure brevity in your answer.  0.97. What is the ratio of the Gross enrolment ratio (%) in Peru in 1989 to that in 1992?
Provide a short and direct response. 1.02. What is the ratio of the Gross enrolment ratio (%) in Suriname in 1989 to that in 1992?
Keep it short and to the point. 0.92. What is the ratio of the Gross enrolment ratio (%) of Europe(all income levels) in 1989 to that in 1993?
Offer a terse response. 0.98. What is the ratio of the Gross enrolment ratio (%) in Panama in 1989 to that in 1993?
Provide a succinct answer. 0.95. What is the ratio of the Gross enrolment ratio (%) in Peru in 1989 to that in 1993?
Give a very brief answer. 1.02. What is the ratio of the Gross enrolment ratio (%) of Suriname in 1989 to that in 1993?
Make the answer very short. 1.08. What is the ratio of the Gross enrolment ratio (%) in Europe(all income levels) in 1989 to that in 2001?
Provide a succinct answer. 0.94. What is the ratio of the Gross enrolment ratio (%) in Panama in 1989 to that in 2001?
Your answer should be very brief. 0.86. What is the ratio of the Gross enrolment ratio (%) of Peru in 1989 to that in 2001?
Provide a succinct answer. 0.76. What is the ratio of the Gross enrolment ratio (%) in Suriname in 1989 to that in 2001?
Your response must be concise. 0.78. What is the ratio of the Gross enrolment ratio (%) of Europe(all income levels) in 1989 to that in 2002?
Ensure brevity in your answer.  0.93. What is the ratio of the Gross enrolment ratio (%) of Panama in 1989 to that in 2002?
Your answer should be very brief. 0.84. What is the ratio of the Gross enrolment ratio (%) of Peru in 1989 to that in 2002?
Provide a short and direct response. 0.75. What is the ratio of the Gross enrolment ratio (%) of Suriname in 1989 to that in 2002?
Ensure brevity in your answer.  0.77. What is the ratio of the Gross enrolment ratio (%) of Europe(all income levels) in 1990 to that in 1991?
Offer a terse response. 1. What is the ratio of the Gross enrolment ratio (%) in Peru in 1990 to that in 1991?
Make the answer very short. 1.01. What is the ratio of the Gross enrolment ratio (%) of Suriname in 1990 to that in 1991?
Your answer should be compact. 0.97. What is the ratio of the Gross enrolment ratio (%) in Europe(all income levels) in 1990 to that in 1992?
Your response must be concise. 1. What is the ratio of the Gross enrolment ratio (%) in Peru in 1990 to that in 1992?
Offer a terse response. 1.03. What is the ratio of the Gross enrolment ratio (%) in Suriname in 1990 to that in 1992?
Give a very brief answer. 0.91. What is the ratio of the Gross enrolment ratio (%) in Europe(all income levels) in 1990 to that in 1993?
Your answer should be compact. 0.98. What is the ratio of the Gross enrolment ratio (%) of Panama in 1990 to that in 1993?
Your answer should be compact. 0.97. What is the ratio of the Gross enrolment ratio (%) in Peru in 1990 to that in 1993?
Offer a terse response. 1.03. What is the ratio of the Gross enrolment ratio (%) in Suriname in 1990 to that in 1993?
Your answer should be compact. 1.07. What is the ratio of the Gross enrolment ratio (%) of Europe(all income levels) in 1990 to that in 2001?
Make the answer very short. 0.94. What is the ratio of the Gross enrolment ratio (%) in Panama in 1990 to that in 2001?
Give a very brief answer. 0.88. What is the ratio of the Gross enrolment ratio (%) in Peru in 1990 to that in 2001?
Provide a succinct answer. 0.77. What is the ratio of the Gross enrolment ratio (%) in Suriname in 1990 to that in 2001?
Ensure brevity in your answer.  0.77. What is the ratio of the Gross enrolment ratio (%) of Europe(all income levels) in 1990 to that in 2002?
Your answer should be very brief. 0.93. What is the ratio of the Gross enrolment ratio (%) of Panama in 1990 to that in 2002?
Give a very brief answer. 0.86. What is the ratio of the Gross enrolment ratio (%) in Peru in 1990 to that in 2002?
Ensure brevity in your answer.  0.76. What is the ratio of the Gross enrolment ratio (%) of Suriname in 1990 to that in 2002?
Offer a terse response. 0.76. What is the ratio of the Gross enrolment ratio (%) in Peru in 1991 to that in 1992?
Offer a very short reply. 1.02. What is the ratio of the Gross enrolment ratio (%) in Suriname in 1991 to that in 1992?
Provide a succinct answer. 0.93. What is the ratio of the Gross enrolment ratio (%) of Europe(all income levels) in 1991 to that in 1993?
Provide a succinct answer. 0.98. What is the ratio of the Gross enrolment ratio (%) of Panama in 1991 to that in 1993?
Offer a terse response. 0.97. What is the ratio of the Gross enrolment ratio (%) in Peru in 1991 to that in 1993?
Your answer should be very brief. 1.02. What is the ratio of the Gross enrolment ratio (%) of Suriname in 1991 to that in 1993?
Make the answer very short. 1.1. What is the ratio of the Gross enrolment ratio (%) of Europe(all income levels) in 1991 to that in 2001?
Keep it short and to the point. 0.94. What is the ratio of the Gross enrolment ratio (%) in Panama in 1991 to that in 2001?
Ensure brevity in your answer.  0.88. What is the ratio of the Gross enrolment ratio (%) of Peru in 1991 to that in 2001?
Your response must be concise. 0.76. What is the ratio of the Gross enrolment ratio (%) in Suriname in 1991 to that in 2001?
Keep it short and to the point. 0.79. What is the ratio of the Gross enrolment ratio (%) of Europe(all income levels) in 1991 to that in 2002?
Offer a terse response. 0.93. What is the ratio of the Gross enrolment ratio (%) in Panama in 1991 to that in 2002?
Offer a terse response. 0.87. What is the ratio of the Gross enrolment ratio (%) of Peru in 1991 to that in 2002?
Offer a terse response. 0.75. What is the ratio of the Gross enrolment ratio (%) in Suriname in 1991 to that in 2002?
Give a very brief answer. 0.78. What is the ratio of the Gross enrolment ratio (%) in Europe(all income levels) in 1992 to that in 1993?
Give a very brief answer. 0.98. What is the ratio of the Gross enrolment ratio (%) in Panama in 1992 to that in 1993?
Make the answer very short. 0.98. What is the ratio of the Gross enrolment ratio (%) in Peru in 1992 to that in 1993?
Make the answer very short. 1. What is the ratio of the Gross enrolment ratio (%) of Suriname in 1992 to that in 1993?
Your response must be concise. 1.18. What is the ratio of the Gross enrolment ratio (%) in Europe(all income levels) in 1992 to that in 2001?
Make the answer very short. 0.94. What is the ratio of the Gross enrolment ratio (%) in Panama in 1992 to that in 2001?
Your answer should be very brief. 0.89. What is the ratio of the Gross enrolment ratio (%) in Peru in 1992 to that in 2001?
Your answer should be very brief. 0.75. What is the ratio of the Gross enrolment ratio (%) of Suriname in 1992 to that in 2001?
Provide a succinct answer. 0.85. What is the ratio of the Gross enrolment ratio (%) of Europe(all income levels) in 1992 to that in 2002?
Ensure brevity in your answer.  0.93. What is the ratio of the Gross enrolment ratio (%) in Panama in 1992 to that in 2002?
Give a very brief answer. 0.87. What is the ratio of the Gross enrolment ratio (%) in Peru in 1992 to that in 2002?
Keep it short and to the point. 0.74. What is the ratio of the Gross enrolment ratio (%) of Suriname in 1992 to that in 2002?
Your answer should be very brief. 0.83. What is the ratio of the Gross enrolment ratio (%) in Europe(all income levels) in 1993 to that in 2001?
Make the answer very short. 0.96. What is the ratio of the Gross enrolment ratio (%) in Panama in 1993 to that in 2001?
Keep it short and to the point. 0.91. What is the ratio of the Gross enrolment ratio (%) of Peru in 1993 to that in 2001?
Your answer should be compact. 0.74. What is the ratio of the Gross enrolment ratio (%) of Suriname in 1993 to that in 2001?
Offer a very short reply. 0.72. What is the ratio of the Gross enrolment ratio (%) in Europe(all income levels) in 1993 to that in 2002?
Your answer should be compact. 0.95. What is the ratio of the Gross enrolment ratio (%) of Panama in 1993 to that in 2002?
Offer a terse response. 0.89. What is the ratio of the Gross enrolment ratio (%) of Peru in 1993 to that in 2002?
Offer a terse response. 0.73. What is the ratio of the Gross enrolment ratio (%) in Suriname in 1993 to that in 2002?
Offer a terse response. 0.71. What is the ratio of the Gross enrolment ratio (%) of Europe(all income levels) in 2001 to that in 2002?
Provide a short and direct response. 0.99. What is the ratio of the Gross enrolment ratio (%) of Panama in 2001 to that in 2002?
Give a very brief answer. 0.98. What is the difference between the highest and the second highest Gross enrolment ratio (%) in Europe(all income levels)?
Keep it short and to the point. 0.97. What is the difference between the highest and the second highest Gross enrolment ratio (%) in Panama?
Keep it short and to the point. 1.27. What is the difference between the highest and the second highest Gross enrolment ratio (%) in Peru?
Keep it short and to the point. 1.09. What is the difference between the highest and the second highest Gross enrolment ratio (%) of Suriname?
Offer a terse response. 0.96. What is the difference between the highest and the lowest Gross enrolment ratio (%) of Europe(all income levels)?
Provide a succinct answer. 6.49. What is the difference between the highest and the lowest Gross enrolment ratio (%) in Panama?
Make the answer very short. 10.59. What is the difference between the highest and the lowest Gross enrolment ratio (%) of Peru?
Offer a terse response. 23.56. What is the difference between the highest and the lowest Gross enrolment ratio (%) of Suriname?
Provide a succinct answer. 21.56. 